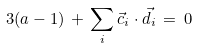Convert formula to latex. <formula><loc_0><loc_0><loc_500><loc_500>3 ( a - 1 ) \, + \, \sum _ { i } \vec { c } _ { i } \cdot \vec { d } _ { i } \, = \, 0</formula> 